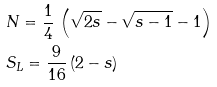<formula> <loc_0><loc_0><loc_500><loc_500>& N = \frac { 1 } { 4 } \, \left ( \sqrt { 2 s } - \sqrt { s - 1 } - 1 \right ) \\ & S _ { L } = \frac { 9 } { 1 6 } \, ( 2 - s )</formula> 